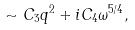<formula> <loc_0><loc_0><loc_500><loc_500>\sim C _ { 3 } q ^ { 2 } + i C _ { 4 } \omega ^ { 5 / 4 } ,</formula> 